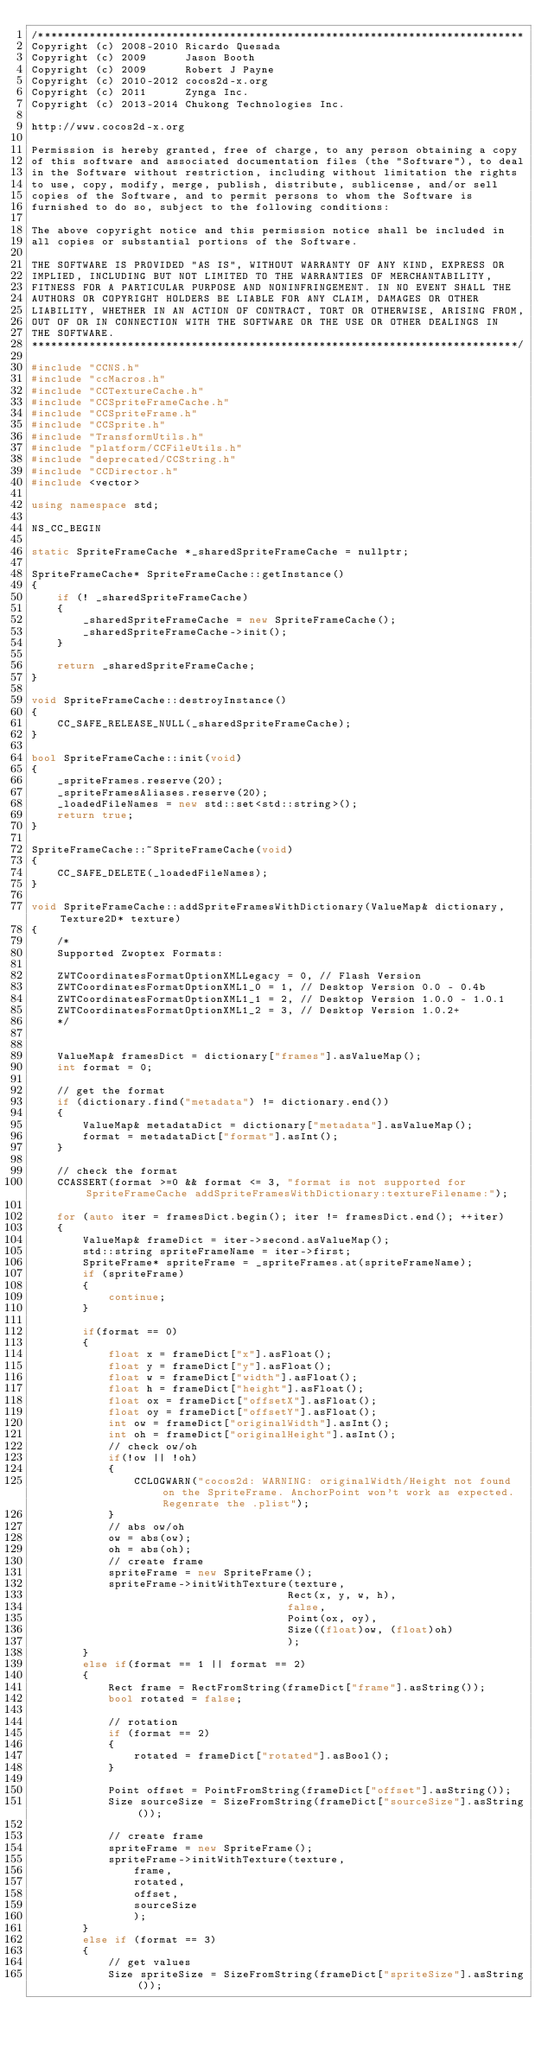<code> <loc_0><loc_0><loc_500><loc_500><_C++_>/****************************************************************************
Copyright (c) 2008-2010 Ricardo Quesada
Copyright (c) 2009      Jason Booth
Copyright (c) 2009      Robert J Payne
Copyright (c) 2010-2012 cocos2d-x.org
Copyright (c) 2011      Zynga Inc.
Copyright (c) 2013-2014 Chukong Technologies Inc.

http://www.cocos2d-x.org

Permission is hereby granted, free of charge, to any person obtaining a copy
of this software and associated documentation files (the "Software"), to deal
in the Software without restriction, including without limitation the rights
to use, copy, modify, merge, publish, distribute, sublicense, and/or sell
copies of the Software, and to permit persons to whom the Software is
furnished to do so, subject to the following conditions:

The above copyright notice and this permission notice shall be included in
all copies or substantial portions of the Software.

THE SOFTWARE IS PROVIDED "AS IS", WITHOUT WARRANTY OF ANY KIND, EXPRESS OR
IMPLIED, INCLUDING BUT NOT LIMITED TO THE WARRANTIES OF MERCHANTABILITY,
FITNESS FOR A PARTICULAR PURPOSE AND NONINFRINGEMENT. IN NO EVENT SHALL THE
AUTHORS OR COPYRIGHT HOLDERS BE LIABLE FOR ANY CLAIM, DAMAGES OR OTHER
LIABILITY, WHETHER IN AN ACTION OF CONTRACT, TORT OR OTHERWISE, ARISING FROM,
OUT OF OR IN CONNECTION WITH THE SOFTWARE OR THE USE OR OTHER DEALINGS IN
THE SOFTWARE.
****************************************************************************/

#include "CCNS.h"
#include "ccMacros.h"
#include "CCTextureCache.h"
#include "CCSpriteFrameCache.h"
#include "CCSpriteFrame.h"
#include "CCSprite.h"
#include "TransformUtils.h"
#include "platform/CCFileUtils.h"
#include "deprecated/CCString.h"
#include "CCDirector.h"
#include <vector>

using namespace std;

NS_CC_BEGIN

static SpriteFrameCache *_sharedSpriteFrameCache = nullptr;

SpriteFrameCache* SpriteFrameCache::getInstance()
{
    if (! _sharedSpriteFrameCache)
    {
        _sharedSpriteFrameCache = new SpriteFrameCache();
        _sharedSpriteFrameCache->init();
    }

    return _sharedSpriteFrameCache;
}

void SpriteFrameCache::destroyInstance()
{
    CC_SAFE_RELEASE_NULL(_sharedSpriteFrameCache);
}

bool SpriteFrameCache::init(void)
{
    _spriteFrames.reserve(20);
    _spriteFramesAliases.reserve(20);
    _loadedFileNames = new std::set<std::string>();
    return true;
}

SpriteFrameCache::~SpriteFrameCache(void)
{
    CC_SAFE_DELETE(_loadedFileNames);
}

void SpriteFrameCache::addSpriteFramesWithDictionary(ValueMap& dictionary, Texture2D* texture)
{
    /*
    Supported Zwoptex Formats:

    ZWTCoordinatesFormatOptionXMLLegacy = 0, // Flash Version
    ZWTCoordinatesFormatOptionXML1_0 = 1, // Desktop Version 0.0 - 0.4b
    ZWTCoordinatesFormatOptionXML1_1 = 2, // Desktop Version 1.0.0 - 1.0.1
    ZWTCoordinatesFormatOptionXML1_2 = 3, // Desktop Version 1.0.2+
    */

    
    ValueMap& framesDict = dictionary["frames"].asValueMap();
    int format = 0;

    // get the format
    if (dictionary.find("metadata") != dictionary.end())
    {
        ValueMap& metadataDict = dictionary["metadata"].asValueMap();
        format = metadataDict["format"].asInt();
    }

    // check the format
    CCASSERT(format >=0 && format <= 3, "format is not supported for SpriteFrameCache addSpriteFramesWithDictionary:textureFilename:");

    for (auto iter = framesDict.begin(); iter != framesDict.end(); ++iter)
    {
        ValueMap& frameDict = iter->second.asValueMap();
        std::string spriteFrameName = iter->first;
        SpriteFrame* spriteFrame = _spriteFrames.at(spriteFrameName);
        if (spriteFrame)
        {
            continue;
        }
        
        if(format == 0) 
        {
            float x = frameDict["x"].asFloat();
            float y = frameDict["y"].asFloat();
            float w = frameDict["width"].asFloat();
            float h = frameDict["height"].asFloat();
            float ox = frameDict["offsetX"].asFloat();
            float oy = frameDict["offsetY"].asFloat();
            int ow = frameDict["originalWidth"].asInt();
            int oh = frameDict["originalHeight"].asInt();
            // check ow/oh
            if(!ow || !oh)
            {
                CCLOGWARN("cocos2d: WARNING: originalWidth/Height not found on the SpriteFrame. AnchorPoint won't work as expected. Regenrate the .plist");
            }
            // abs ow/oh
            ow = abs(ow);
            oh = abs(oh);
            // create frame
            spriteFrame = new SpriteFrame();
            spriteFrame->initWithTexture(texture,
                                        Rect(x, y, w, h), 
                                        false,
                                        Point(ox, oy),
                                        Size((float)ow, (float)oh)
                                        );
        } 
        else if(format == 1 || format == 2) 
        {
            Rect frame = RectFromString(frameDict["frame"].asString());
            bool rotated = false;

            // rotation
            if (format == 2)
            {
                rotated = frameDict["rotated"].asBool();
            }

            Point offset = PointFromString(frameDict["offset"].asString());
            Size sourceSize = SizeFromString(frameDict["sourceSize"].asString());

            // create frame
            spriteFrame = new SpriteFrame();
            spriteFrame->initWithTexture(texture,
                frame,
                rotated,
                offset,
                sourceSize
                );
        } 
        else if (format == 3)
        {
            // get values
            Size spriteSize = SizeFromString(frameDict["spriteSize"].asString());</code> 